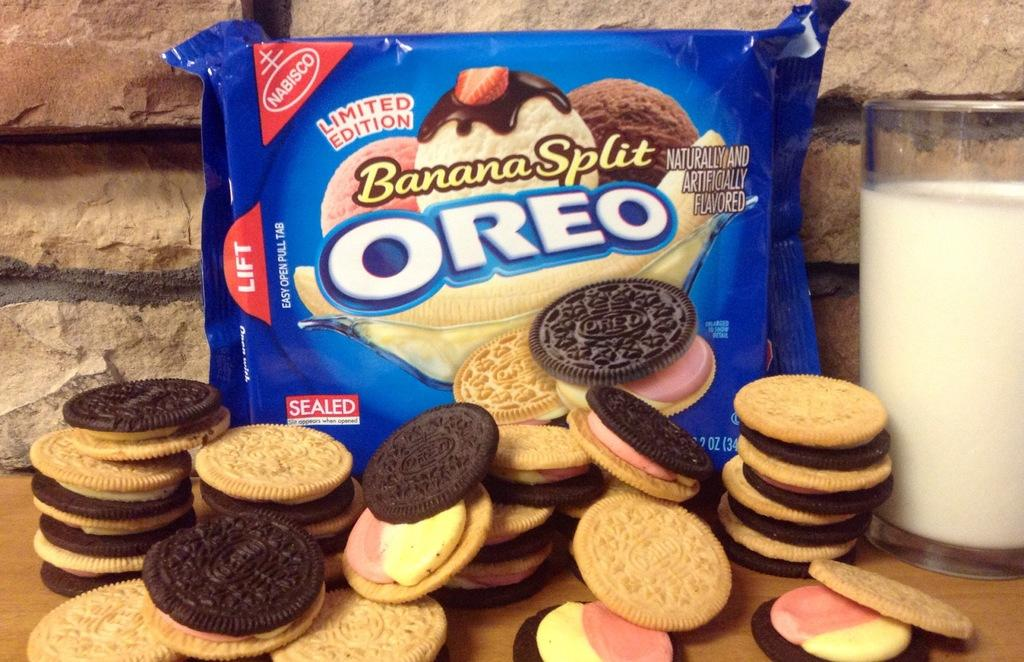What type of food is visible in the image? There are biscuits in the image. What beverage is present in the image? There is a glass of milk in the image. How are the biscuits packaged in the image? There is a pack of biscuits in the image. What can be seen in the background of the image? There is a wall in the background of the image. What type of song is playing in the background of the image? There is no indication of any music or song playing in the image. 